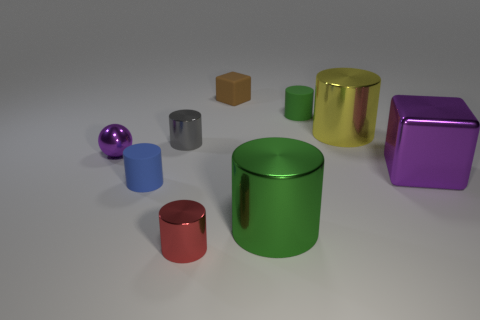Add 1 tiny blue rubber objects. How many objects exist? 10 Subtract all green rubber cylinders. How many cylinders are left? 5 Subtract 1 blocks. How many blocks are left? 1 Subtract all blue spheres. How many brown cubes are left? 1 Subtract all red cylinders. How many cylinders are left? 5 Subtract all cubes. How many objects are left? 7 Subtract all small red metallic cylinders. Subtract all purple metal cubes. How many objects are left? 7 Add 4 big green metal cylinders. How many big green metal cylinders are left? 5 Add 1 big yellow cylinders. How many big yellow cylinders exist? 2 Subtract 0 purple cylinders. How many objects are left? 9 